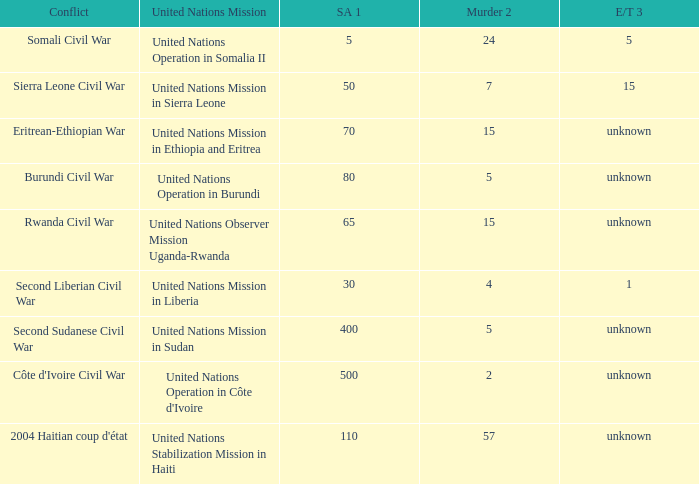What is the extortion and theft rates where the United Nations Observer Mission Uganda-Rwanda is active? Unknown. 